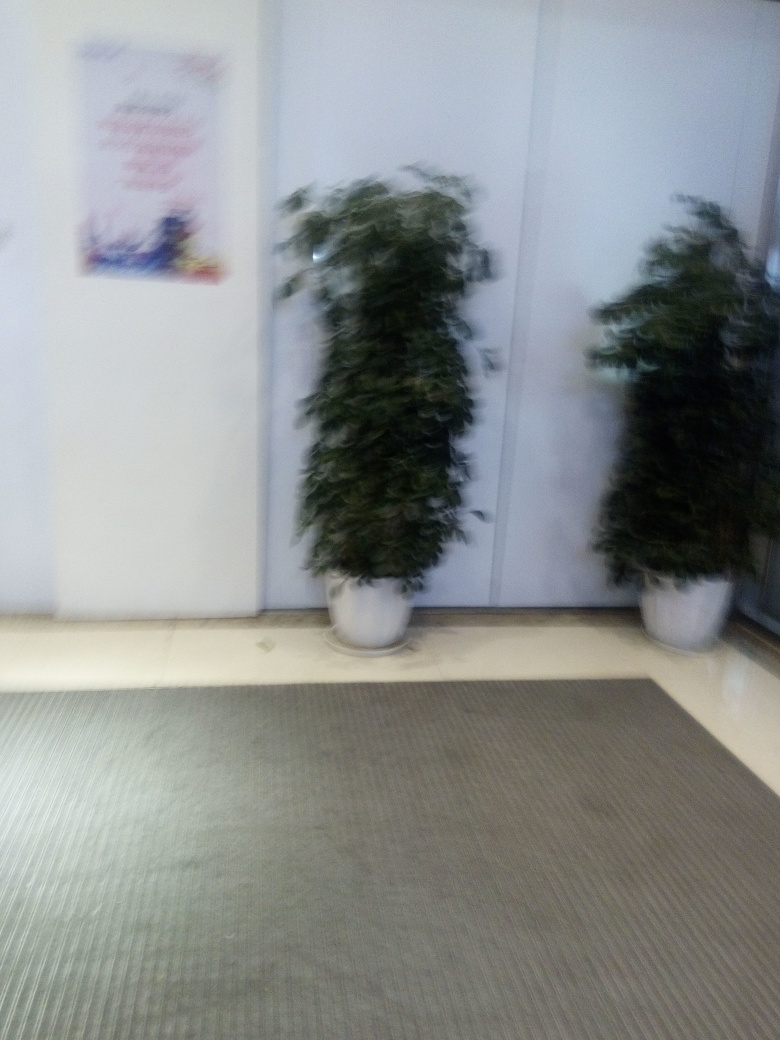How might the composition of this photo be improved? Improving the composition of this photo could involve a few tactics. Firstly, ensuring the camera focus is sharp would drastically enhance the clarity of the image. Positioning the plants to follow the rule of thirds, which means off-centering the subjects, could also add visual interest. Furthermore, capturing the image from a lower angle might provide a unique perspective, highlighting the plants' structure and texture against their environment. 